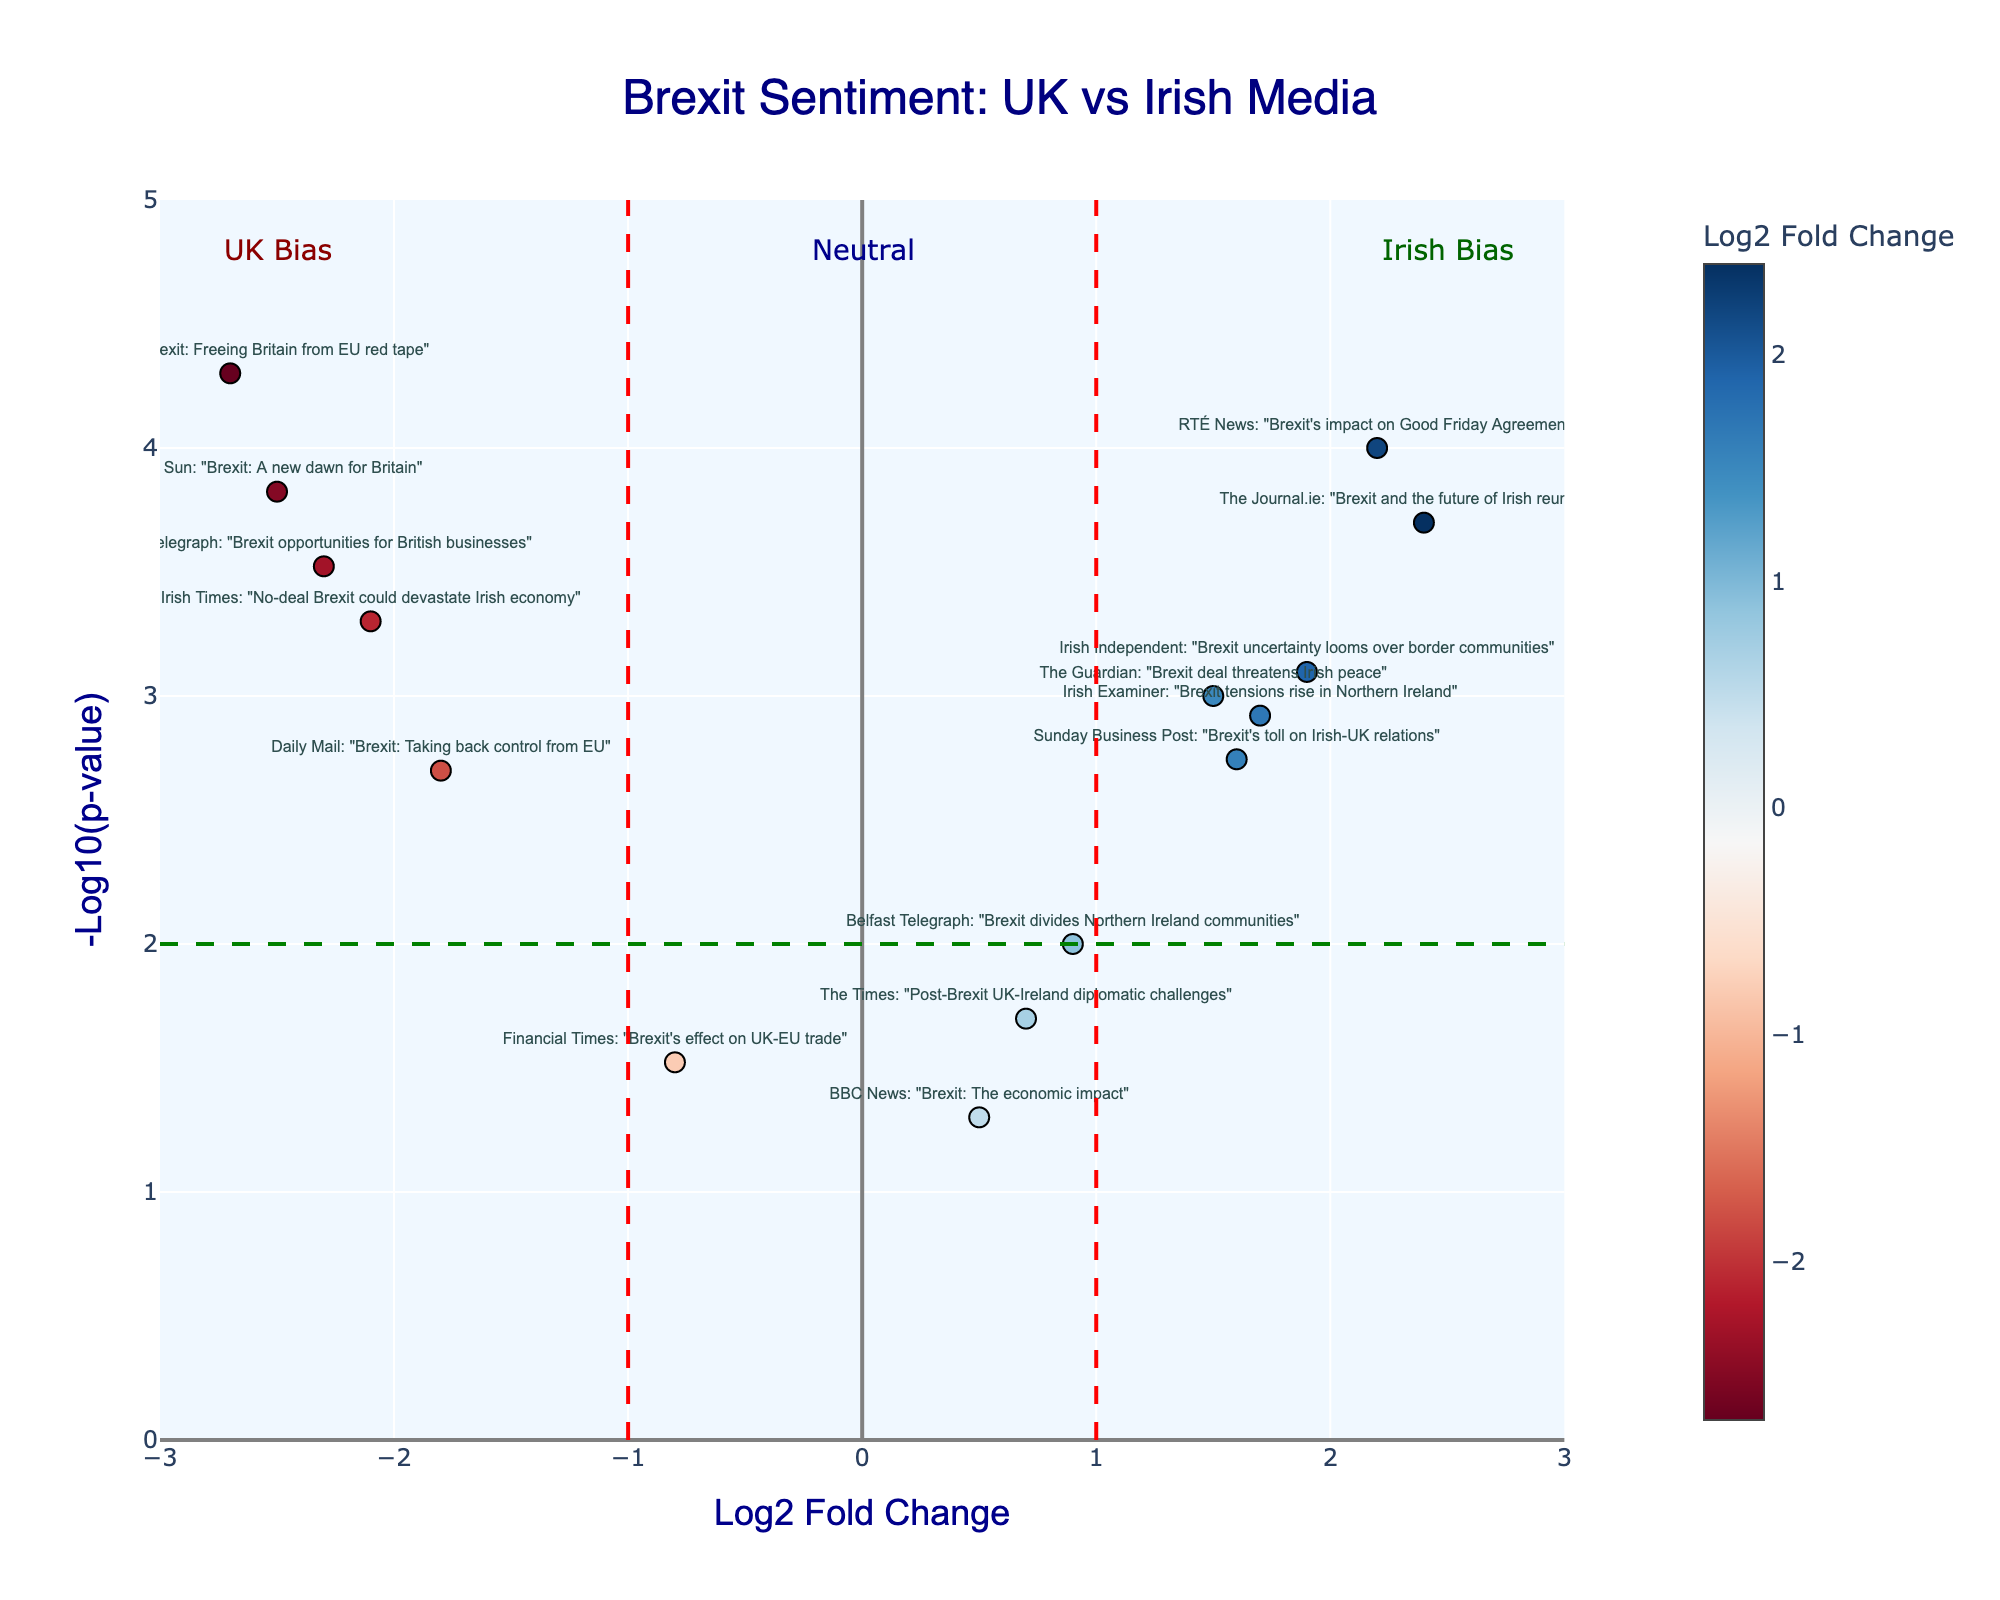How many data points are on the plot? Count the total number of data points from the figure. Each data point represents one article title.
Answer: 15 What's the title of the article with the highest negative log2 fold change? Look at the point furthest to the left on the x-axis in the figure. The title above that point is "Daily Express: Brexit: Freeing Britain from EU red tape."
Answer: "Daily Express: Brexit: Freeing Britain from EU red tape" Which article has the smallest p-value? Identify the data point with the highest y-value, as the p-value is inversely related to the height on the y-axis. The corresponding title is "RTÉ News: Brexit's impact on Good Friday Agreement."
Answer: "RTÉ News: Brexit's impact on Good Friday Agreement" How many articles are biased towards the Irish perspective? Count the number of data points to the right of the vertical line at x=1. These points have a log2 fold change greater than 1. There are 6 such articles.
Answer: 6 What's the log2 fold change and p-value of "Financial Times: Brexit's effect on UK-EU trade"? Find the data point with the title "Financial Times: Brexit's effect on UK-EU trade." The log2 fold change is around -0.8 and the y-value translates to a p-value which is about 0.03.
Answer: Log2 fold change: -0.8, p-value: 0.03 Compare the log2 fold changes of "The Journal.ie: Brexit and the future of Irish reunification" and "The Sun: Brexit: A new dawn for Britain". Which one is higher? Look at the x-values for both titles. "The Journal.ie: Brexit and the future of Irish reunification" has a log2 fold change of 2.4, while "The Sun: Brexit: A new dawn for Britain" has a log2 fold change of -2.5. The value for "The Journal.ie" is higher.
Answer: "The Journal.ie: Brexit and the future of Irish reunification" What's the minimum p-value threshold indicated by the green dashed horizontal line? Identify the y-value where the green dashed horizontal line is located. This represents the minimum significant p-value threshold, which is 2 on the -log10 scale. Converting -log10(2) gives a p-value of 0.01.
Answer: 0.01 Are there more articles that show UK bias or Irish bias? Compare the number of points to the left of the vertical line at x=-1 (UK bias) with those to the right of the line at x=1 (Irish bias). There are 6 articles showing UK bias and 6 articles showing Irish bias. Therefore, they are equal.
Answer: Equal (6 each) What is the overall trend in sentiment between UK and Irish media regarding Brexit? Evaluate the distribution of points across the x-axis. Articles from Irish sources tend to be on the right, indicating a more negative sentiment towards Brexit, while articles from UK sources are on the left, displaying a more positive or supportive sentiment towards Brexit.
Answer: Diverging, with UK media being more positive 